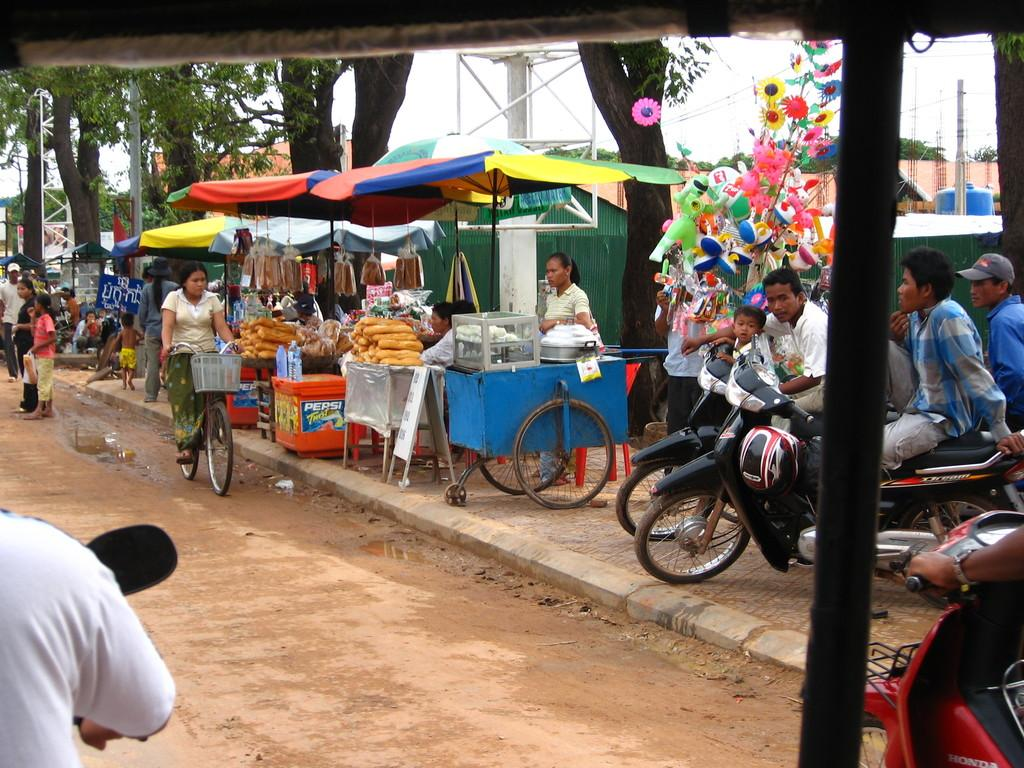Who can be seen in the image? There are people in the image. What else is present in the image besides people? There are vehicles, a woman riding a bicycle, stalls, toys, trees, poles, and the sky visible in the background. What type of activity is the woman on the bicycle engaged in? The woman is riding a bicycle. What can be found at the stalls in the image? The image does not specify what is being sold at the stalls. What is visible in the background of the image? Trees, poles, and the sky are visible in the background of the image. What type of trousers is the woman wearing while riding the bicycle? The image does not provide information about the woman's trousers. How many boxes can be seen in the image? There are no boxes present in the image. 